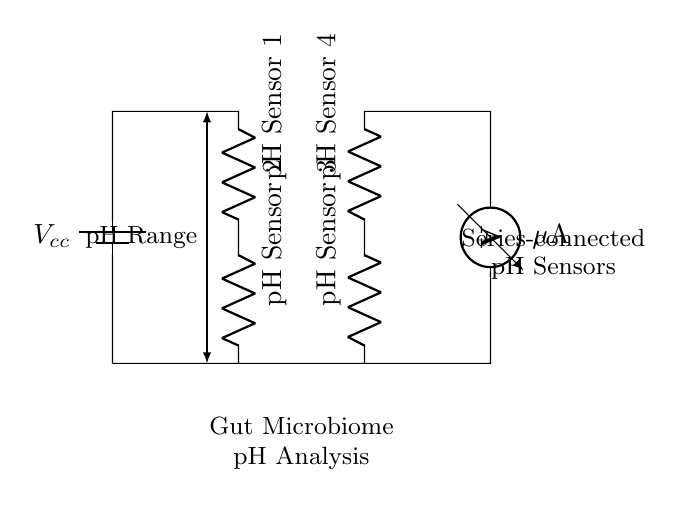What is the total number of pH sensors in this circuit? The circuit diagram shows four distinct pH sensors connected in series; each sensor is labeled clearly. Therefore, counting these gives us the total number of sensors.
Answer: Four What type of current is measured in this circuit? The circuit includes an ammeter that measures the current passing through the connected pH sensors, represented by the unit microamperes, indicating it is a measurement of direct current.
Answer: Microamperes What is the role of the battery in this circuit? The battery provides the necessary voltage supply to power all components in the circuit, allowing the pH sensors to function properly and emit relevant measurements.
Answer: Voltage supply If one pH sensor fails, what happens to the others? Since the sensors are arranged in series, a failure in one sensor would break the circuit and stop current flow, thus preventing any pH analysis from occurring for the entire system, as all components in a series circuit must function properly.
Answer: Circuit failure What is the purpose of the series connection in this circuit? The series connection allows for cumulative voltage drops across each pH sensor, facilitating the overall monitoring of pH levels in the gut microbiome effectively while using a simpler circuit design with fewer components.
Answer: Cumulative voltage drop What do the labels on the resistors represent in this circuit? The labels represent the individual pH sensors denoted as Sensor 1, Sensor 2, Sensor 3, and Sensor 4, highlighting that these components are specialized for measuring the pH levels in the gut microbiome environment.
Answer: pH sensors 